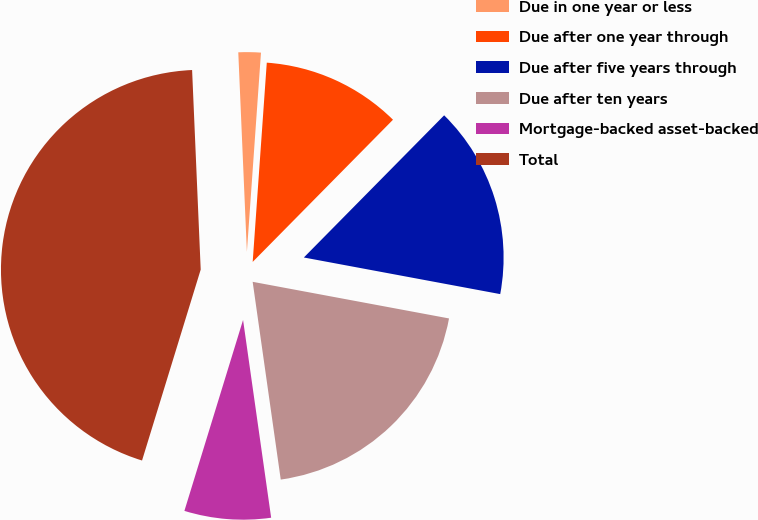Convert chart. <chart><loc_0><loc_0><loc_500><loc_500><pie_chart><fcel>Due in one year or less<fcel>Due after one year through<fcel>Due after five years through<fcel>Due after ten years<fcel>Mortgage-backed asset-backed<fcel>Total<nl><fcel>1.81%<fcel>11.27%<fcel>15.54%<fcel>19.82%<fcel>6.99%<fcel>44.57%<nl></chart> 